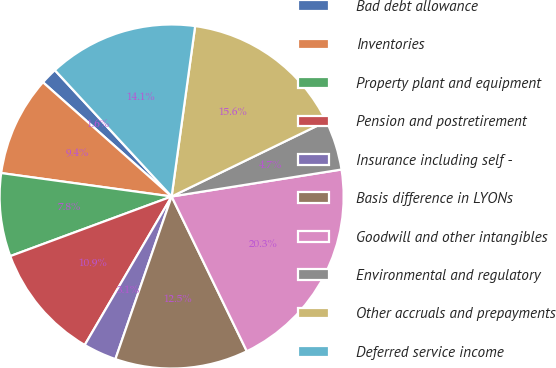Convert chart to OTSL. <chart><loc_0><loc_0><loc_500><loc_500><pie_chart><fcel>Bad debt allowance<fcel>Inventories<fcel>Property plant and equipment<fcel>Pension and postretirement<fcel>Insurance including self -<fcel>Basis difference in LYONs<fcel>Goodwill and other intangibles<fcel>Environmental and regulatory<fcel>Other accruals and prepayments<fcel>Deferred service income<nl><fcel>1.57%<fcel>9.38%<fcel>7.81%<fcel>10.94%<fcel>3.13%<fcel>12.5%<fcel>20.31%<fcel>4.69%<fcel>15.62%<fcel>14.06%<nl></chart> 